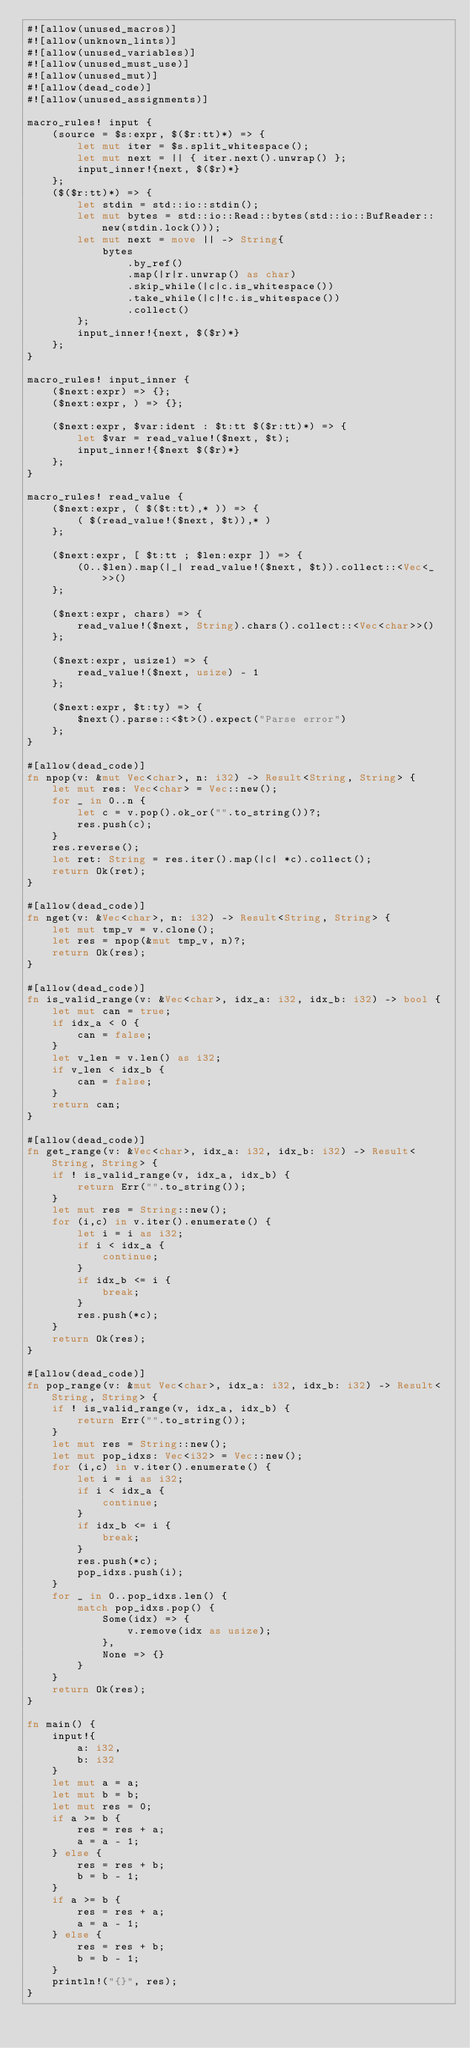<code> <loc_0><loc_0><loc_500><loc_500><_Rust_>#![allow(unused_macros)]
#![allow(unknown_lints)]
#![allow(unused_variables)]
#![allow(unused_must_use)]
#![allow(unused_mut)]
#![allow(dead_code)]
#![allow(unused_assignments)]

macro_rules! input {
    (source = $s:expr, $($r:tt)*) => {
        let mut iter = $s.split_whitespace();
        let mut next = || { iter.next().unwrap() };
        input_inner!{next, $($r)*}
    };
    ($($r:tt)*) => {
        let stdin = std::io::stdin();
        let mut bytes = std::io::Read::bytes(std::io::BufReader::new(stdin.lock()));
        let mut next = move || -> String{
            bytes
                .by_ref()
                .map(|r|r.unwrap() as char)
                .skip_while(|c|c.is_whitespace())
                .take_while(|c|!c.is_whitespace())
                .collect()
        };
        input_inner!{next, $($r)*}
    };
}

macro_rules! input_inner {
    ($next:expr) => {};
    ($next:expr, ) => {};

    ($next:expr, $var:ident : $t:tt $($r:tt)*) => {
        let $var = read_value!($next, $t);
        input_inner!{$next $($r)*}
    };
}

macro_rules! read_value {
    ($next:expr, ( $($t:tt),* )) => {
        ( $(read_value!($next, $t)),* )
    };

    ($next:expr, [ $t:tt ; $len:expr ]) => {
        (0..$len).map(|_| read_value!($next, $t)).collect::<Vec<_>>()
    };

    ($next:expr, chars) => {
        read_value!($next, String).chars().collect::<Vec<char>>()
    };

    ($next:expr, usize1) => {
        read_value!($next, usize) - 1
    };

    ($next:expr, $t:ty) => {
        $next().parse::<$t>().expect("Parse error")
    };
}

#[allow(dead_code)]
fn npop(v: &mut Vec<char>, n: i32) -> Result<String, String> {
    let mut res: Vec<char> = Vec::new();
    for _ in 0..n {
        let c = v.pop().ok_or("".to_string())?;
        res.push(c);
    }
    res.reverse();
    let ret: String = res.iter().map(|c| *c).collect();
    return Ok(ret);
}

#[allow(dead_code)]
fn nget(v: &Vec<char>, n: i32) -> Result<String, String> {
    let mut tmp_v = v.clone();
    let res = npop(&mut tmp_v, n)?;
    return Ok(res);
}

#[allow(dead_code)]
fn is_valid_range(v: &Vec<char>, idx_a: i32, idx_b: i32) -> bool {
    let mut can = true;
    if idx_a < 0 {
        can = false;
    }
    let v_len = v.len() as i32;
    if v_len < idx_b {
        can = false;
    }
    return can;
}

#[allow(dead_code)]
fn get_range(v: &Vec<char>, idx_a: i32, idx_b: i32) -> Result<String, String> {
    if ! is_valid_range(v, idx_a, idx_b) {
        return Err("".to_string());
    }
    let mut res = String::new();
    for (i,c) in v.iter().enumerate() {
        let i = i as i32;
        if i < idx_a {
            continue;
        }
        if idx_b <= i {
            break;
        }
        res.push(*c);
    }
    return Ok(res);
}

#[allow(dead_code)]
fn pop_range(v: &mut Vec<char>, idx_a: i32, idx_b: i32) -> Result<String, String> {
    if ! is_valid_range(v, idx_a, idx_b) {
        return Err("".to_string());
    }
    let mut res = String::new();
    let mut pop_idxs: Vec<i32> = Vec::new();
    for (i,c) in v.iter().enumerate() {
        let i = i as i32;
        if i < idx_a {
            continue;
        }
        if idx_b <= i {
            break;
        }
        res.push(*c);
        pop_idxs.push(i);
    }
    for _ in 0..pop_idxs.len() {
        match pop_idxs.pop() {
            Some(idx) => {
                v.remove(idx as usize);
            },
            None => {}
        }
    }
    return Ok(res);
}

fn main() {
    input!{
        a: i32,
        b: i32
    }
    let mut a = a;
    let mut b = b;
    let mut res = 0;
    if a >= b {
        res = res + a;
        a = a - 1;
    } else {
        res = res + b;
        b = b - 1;
    }
    if a >= b {
        res = res + a;
        a = a - 1;
    } else {
        res = res + b;
        b = b - 1;
    }
    println!("{}", res);
}</code> 